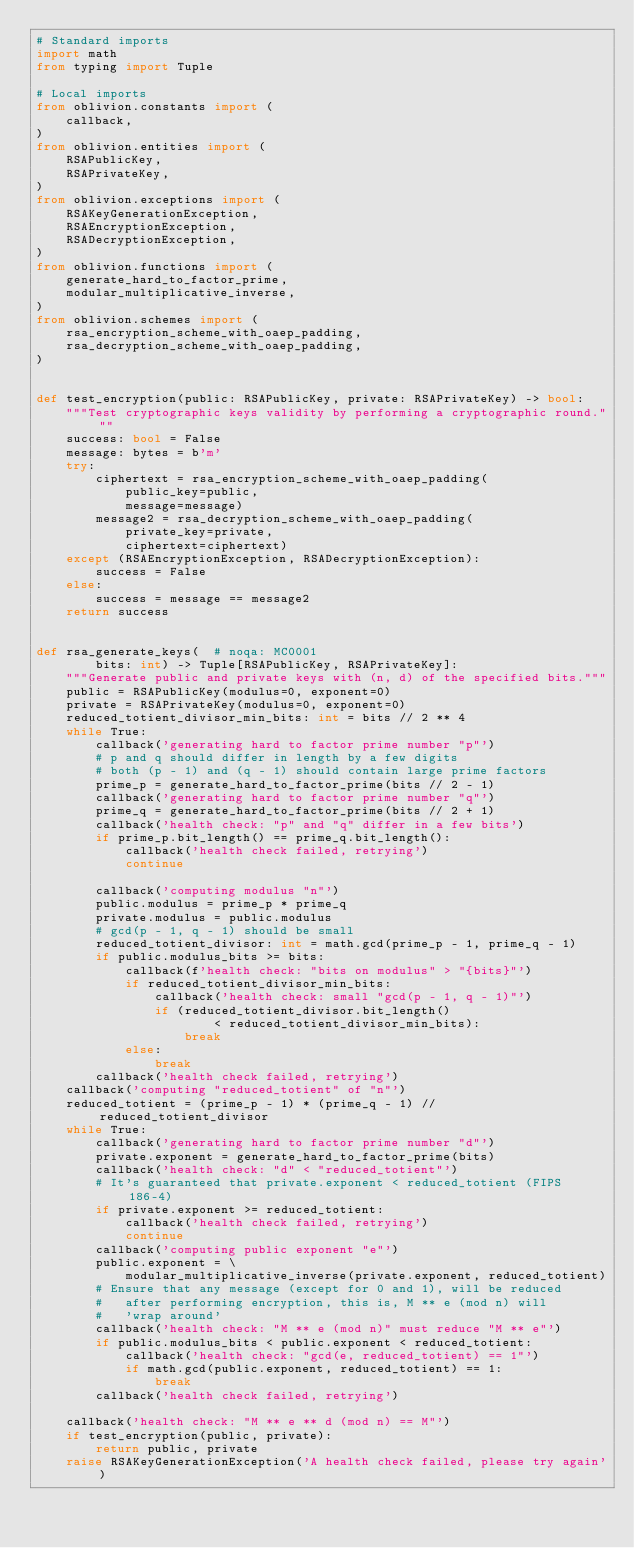<code> <loc_0><loc_0><loc_500><loc_500><_Python_># Standard imports
import math
from typing import Tuple

# Local imports
from oblivion.constants import (
    callback,
)
from oblivion.entities import (
    RSAPublicKey,
    RSAPrivateKey,
)
from oblivion.exceptions import (
    RSAKeyGenerationException,
    RSAEncryptionException,
    RSADecryptionException,
)
from oblivion.functions import (
    generate_hard_to_factor_prime,
    modular_multiplicative_inverse,
)
from oblivion.schemes import (
    rsa_encryption_scheme_with_oaep_padding,
    rsa_decryption_scheme_with_oaep_padding,
)


def test_encryption(public: RSAPublicKey, private: RSAPrivateKey) -> bool:
    """Test cryptographic keys validity by performing a cryptographic round."""
    success: bool = False
    message: bytes = b'm'
    try:
        ciphertext = rsa_encryption_scheme_with_oaep_padding(
            public_key=public,
            message=message)
        message2 = rsa_decryption_scheme_with_oaep_padding(
            private_key=private,
            ciphertext=ciphertext)
    except (RSAEncryptionException, RSADecryptionException):
        success = False
    else:
        success = message == message2
    return success


def rsa_generate_keys(  # noqa: MC0001
        bits: int) -> Tuple[RSAPublicKey, RSAPrivateKey]:
    """Generate public and private keys with (n, d) of the specified bits."""
    public = RSAPublicKey(modulus=0, exponent=0)
    private = RSAPrivateKey(modulus=0, exponent=0)
    reduced_totient_divisor_min_bits: int = bits // 2 ** 4
    while True:
        callback('generating hard to factor prime number "p"')
        # p and q should differ in length by a few digits
        # both (p - 1) and (q - 1) should contain large prime factors
        prime_p = generate_hard_to_factor_prime(bits // 2 - 1)
        callback('generating hard to factor prime number "q"')
        prime_q = generate_hard_to_factor_prime(bits // 2 + 1)
        callback('health check: "p" and "q" differ in a few bits')
        if prime_p.bit_length() == prime_q.bit_length():
            callback('health check failed, retrying')
            continue

        callback('computing modulus "n"')
        public.modulus = prime_p * prime_q
        private.modulus = public.modulus
        # gcd(p - 1, q - 1) should be small
        reduced_totient_divisor: int = math.gcd(prime_p - 1, prime_q - 1)
        if public.modulus_bits >= bits:
            callback(f'health check: "bits on modulus" > "{bits}"')
            if reduced_totient_divisor_min_bits:
                callback('health check: small "gcd(p - 1, q - 1)"')
                if (reduced_totient_divisor.bit_length()
                        < reduced_totient_divisor_min_bits):
                    break
            else:
                break
        callback('health check failed, retrying')
    callback('computing "reduced_totient" of "n"')
    reduced_totient = (prime_p - 1) * (prime_q - 1) // reduced_totient_divisor
    while True:
        callback('generating hard to factor prime number "d"')
        private.exponent = generate_hard_to_factor_prime(bits)
        callback('health check: "d" < "reduced_totient"')
        # It's guaranteed that private.exponent < reduced_totient (FIPS 186-4)
        if private.exponent >= reduced_totient:
            callback('health check failed, retrying')
            continue
        callback('computing public exponent "e"')
        public.exponent = \
            modular_multiplicative_inverse(private.exponent, reduced_totient)
        # Ensure that any message (except for 0 and 1), will be reduced
        #   after performing encryption, this is, M ** e (mod n) will
        #   'wrap around'
        callback('health check: "M ** e (mod n)" must reduce "M ** e"')
        if public.modulus_bits < public.exponent < reduced_totient:
            callback('health check: "gcd(e, reduced_totient) == 1"')
            if math.gcd(public.exponent, reduced_totient) == 1:
                break
        callback('health check failed, retrying')

    callback('health check: "M ** e ** d (mod n) == M"')
    if test_encryption(public, private):
        return public, private
    raise RSAKeyGenerationException('A health check failed, please try again')
</code> 